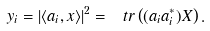<formula> <loc_0><loc_0><loc_500><loc_500>y _ { i } = | \langle a _ { i } , x \rangle | ^ { 2 } = \ t r \left ( ( a _ { i } a _ { i } ^ { * } ) X \right ) .</formula> 